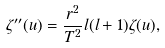Convert formula to latex. <formula><loc_0><loc_0><loc_500><loc_500>\zeta ^ { \prime \prime } ( u ) = \frac { r ^ { 2 } } { T ^ { 2 } } l ( l + 1 ) \zeta ( u ) ,</formula> 